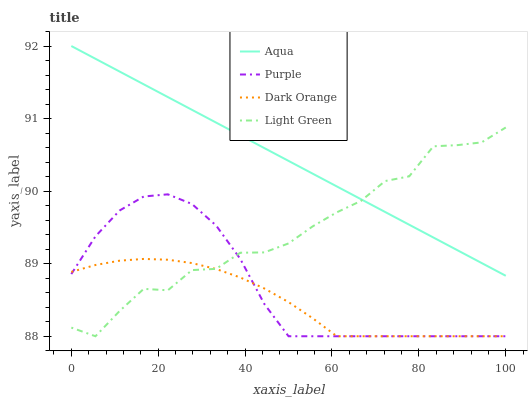Does Dark Orange have the minimum area under the curve?
Answer yes or no. Yes. Does Aqua have the maximum area under the curve?
Answer yes or no. Yes. Does Aqua have the minimum area under the curve?
Answer yes or no. No. Does Dark Orange have the maximum area under the curve?
Answer yes or no. No. Is Aqua the smoothest?
Answer yes or no. Yes. Is Light Green the roughest?
Answer yes or no. Yes. Is Dark Orange the smoothest?
Answer yes or no. No. Is Dark Orange the roughest?
Answer yes or no. No. Does Purple have the lowest value?
Answer yes or no. Yes. Does Aqua have the lowest value?
Answer yes or no. No. Does Aqua have the highest value?
Answer yes or no. Yes. Does Dark Orange have the highest value?
Answer yes or no. No. Is Purple less than Aqua?
Answer yes or no. Yes. Is Aqua greater than Dark Orange?
Answer yes or no. Yes. Does Purple intersect Light Green?
Answer yes or no. Yes. Is Purple less than Light Green?
Answer yes or no. No. Is Purple greater than Light Green?
Answer yes or no. No. Does Purple intersect Aqua?
Answer yes or no. No. 